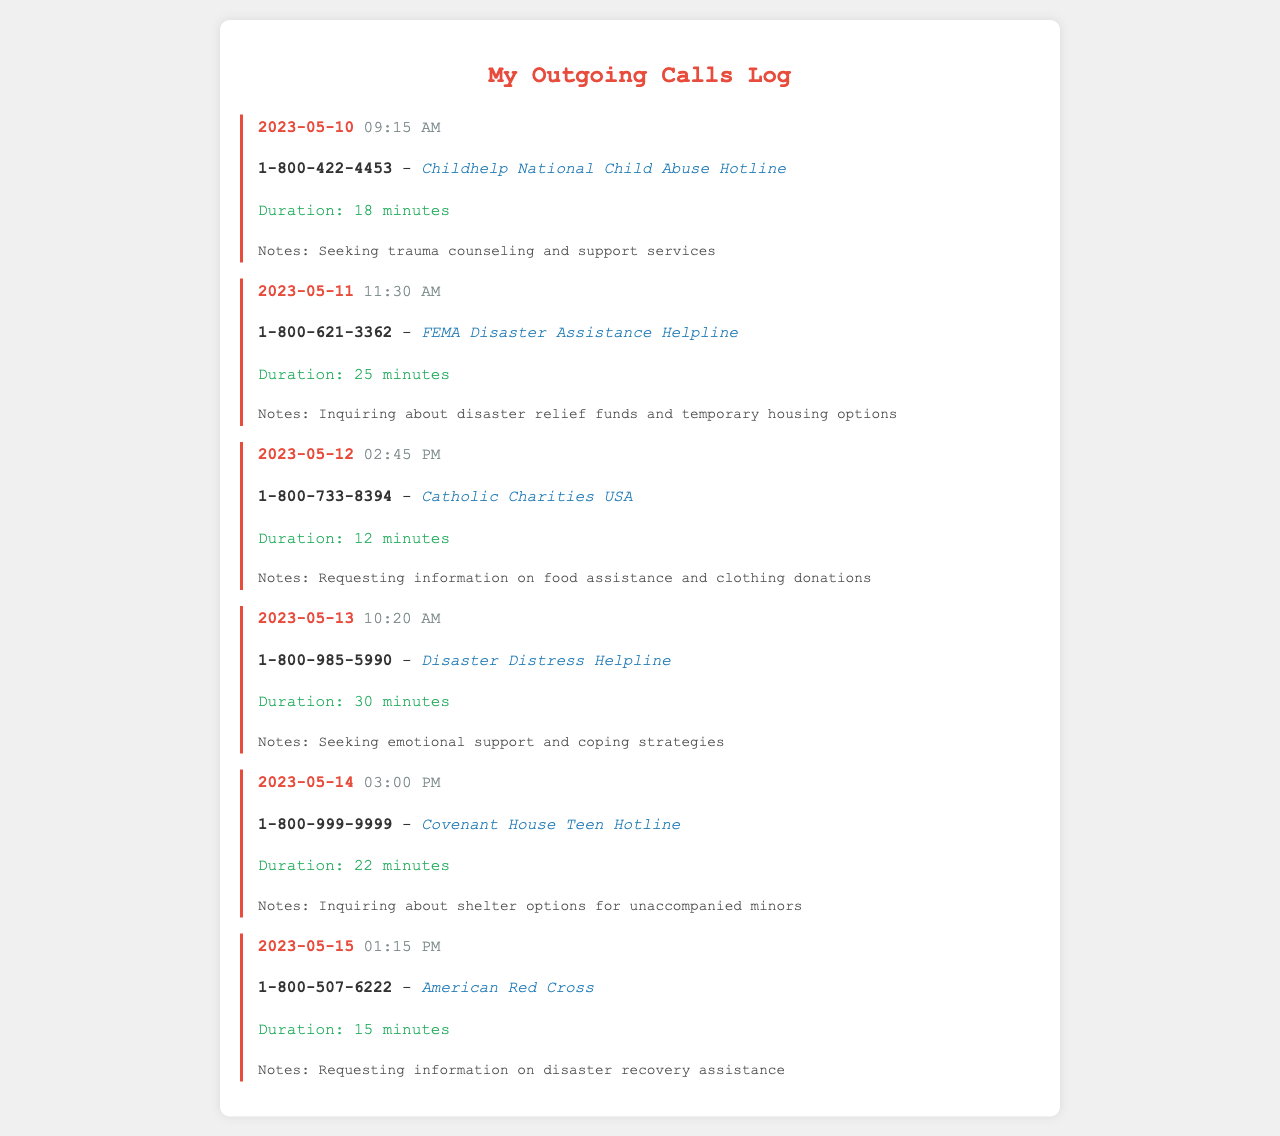what was the call duration with Childhelp National Child Abuse Hotline? The call duration is noted under the call details, which states "Duration: 18 minutes."
Answer: 18 minutes which agency did you contact on May 12, 2023? Each call log includes the agency name along with the date; for May 12, the agency is "Catholic Charities USA."
Answer: Catholic Charities USA what type of assistance was inquired about on May 11, 2023? The notes section specifies the type of assistance sought during the call; on this date, it mentions "disaster relief funds and temporary housing options."
Answer: disaster relief funds and temporary housing options how many minutes did you spend on the call with Disaster Distress Helpline? The duration of the call is mentioned, which states "Duration: 30 minutes" for this particular call.
Answer: 30 minutes which telephone number was called for information on shelter options? The call log includes the number used for the call, which is "1-800-999-9999" for Covenant House Teen Hotline.
Answer: 1-800-999-9999 what type of support was sought from the Disaster Distress Helpline? The notes clearly indicate the type of support requested; in this case, "emotional support and coping strategies."
Answer: emotional support and coping strategies how many total calls are logged in this document? The document lists a total of six separate call logs, indicating the total number of calls made.
Answer: 6 what is the main purpose of contacting American Red Cross? The notes section mentions that the purpose was to request information on "disaster recovery assistance."
Answer: disaster recovery assistance when was the call to Covenant House Teen Hotline made? The call date is provided in the log entry; it indicates that the call was made on "2023-05-14."
Answer: 2023-05-14 